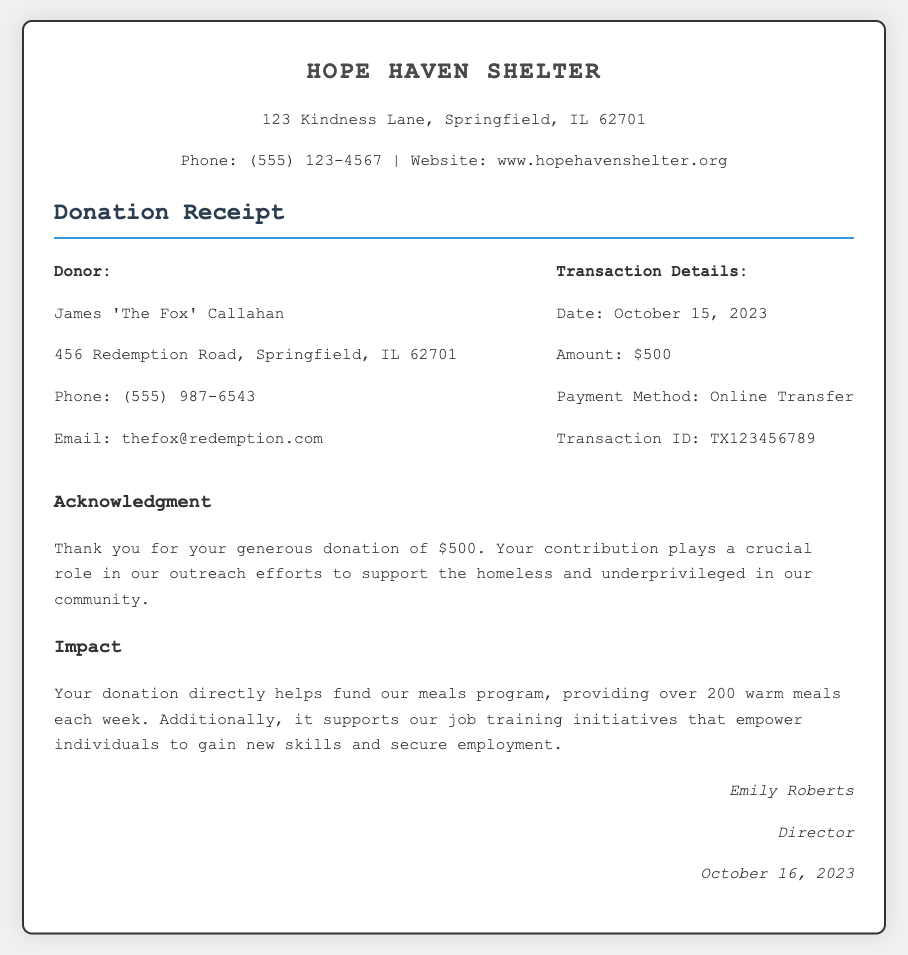What is the name of the shelter? The name of the shelter is clearly stated at the top of the document.
Answer: Hope Haven Shelter Who is the donor? The donor's name is mentioned in the organization information section of the document.
Answer: James 'The Fox' Callahan What is the donation amount? The amount donated is specified in the transaction details section of the receipt.
Answer: $500 What is the transaction ID? The transaction ID is listed under the transaction details.
Answer: TX123456789 When was the donation made? The date of the donation can be found in the transaction details section of the document.
Answer: October 15, 2023 How many warm meals does the donation help provide per week? The impact section indicates how many meals are provided as a result of the donation.
Answer: 200 What does the donation support besides meals? This question requires reasoning from the impact section referring to the different programs funded by the donation.
Answer: Job training initiatives What is the payment method for the donation? The payment method is specified in the transaction details.
Answer: Online Transfer Who is the director of the shelter? The signature at the bottom identifies the director of the organization.
Answer: Emily Roberts 